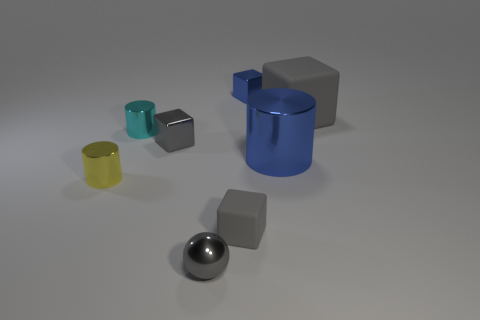Subtract all gray balls. How many gray blocks are left? 3 Add 1 tiny cyan cubes. How many objects exist? 9 Subtract all balls. How many objects are left? 7 Subtract all large brown metal blocks. Subtract all big gray matte things. How many objects are left? 7 Add 5 tiny gray rubber blocks. How many tiny gray rubber blocks are left? 6 Add 1 large blue cylinders. How many large blue cylinders exist? 2 Subtract 0 purple balls. How many objects are left? 8 